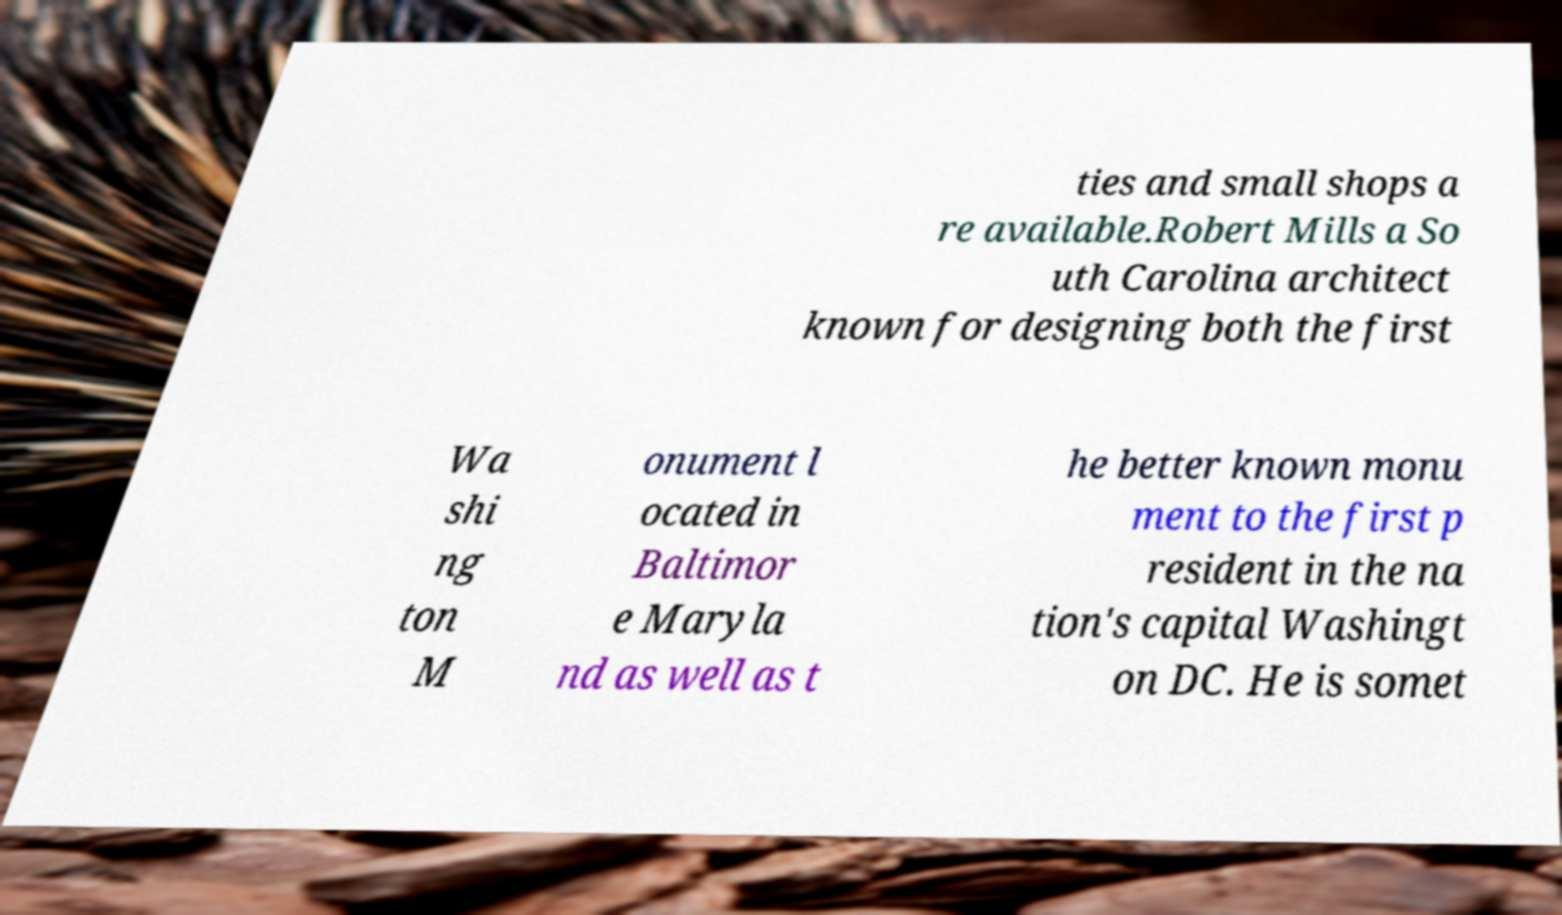Could you assist in decoding the text presented in this image and type it out clearly? ties and small shops a re available.Robert Mills a So uth Carolina architect known for designing both the first Wa shi ng ton M onument l ocated in Baltimor e Maryla nd as well as t he better known monu ment to the first p resident in the na tion's capital Washingt on DC. He is somet 